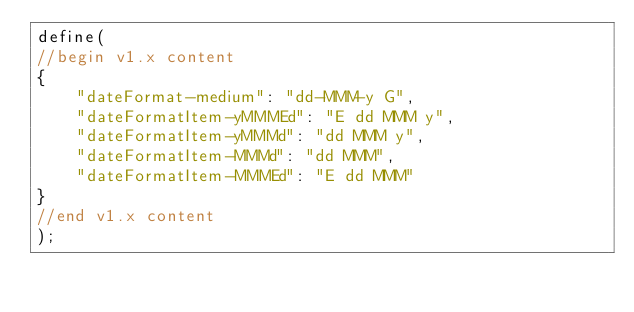Convert code to text. <code><loc_0><loc_0><loc_500><loc_500><_JavaScript_>define(
//begin v1.x content
{
	"dateFormat-medium": "dd-MMM-y G",
	"dateFormatItem-yMMMEd": "E dd MMM y",
	"dateFormatItem-yMMMd": "dd MMM y",
	"dateFormatItem-MMMd": "dd MMM",
	"dateFormatItem-MMMEd": "E dd MMM"
}
//end v1.x content
);</code> 